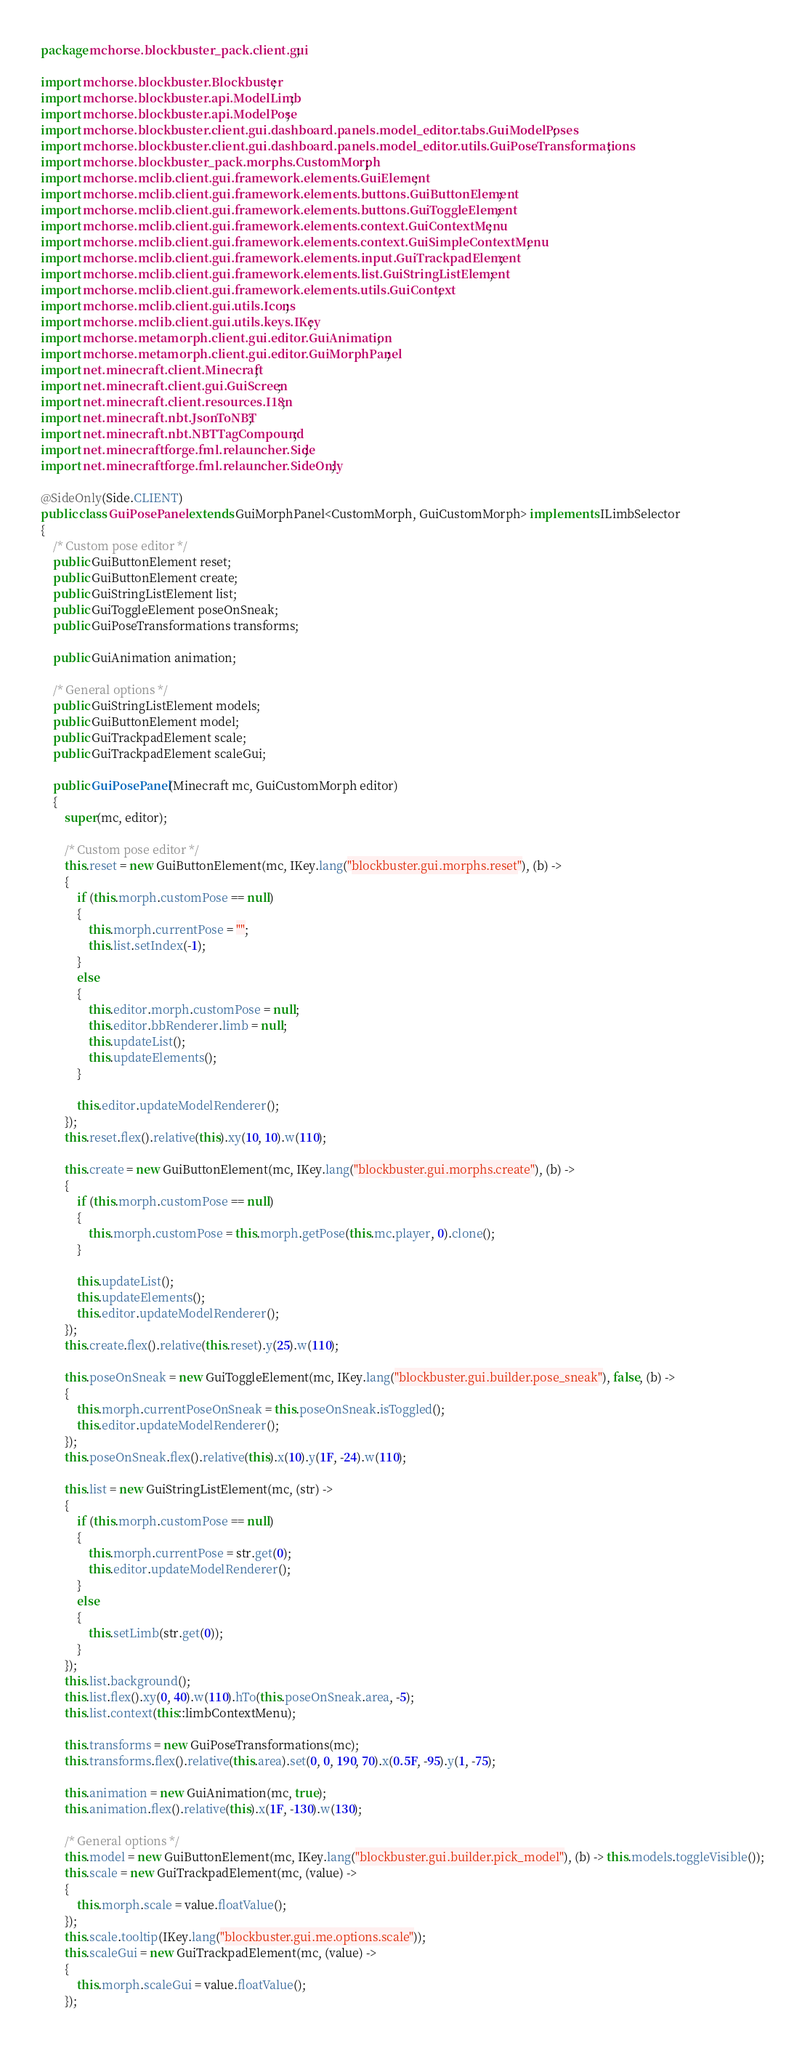Convert code to text. <code><loc_0><loc_0><loc_500><loc_500><_Java_>package mchorse.blockbuster_pack.client.gui;

import mchorse.blockbuster.Blockbuster;
import mchorse.blockbuster.api.ModelLimb;
import mchorse.blockbuster.api.ModelPose;
import mchorse.blockbuster.client.gui.dashboard.panels.model_editor.tabs.GuiModelPoses;
import mchorse.blockbuster.client.gui.dashboard.panels.model_editor.utils.GuiPoseTransformations;
import mchorse.blockbuster_pack.morphs.CustomMorph;
import mchorse.mclib.client.gui.framework.elements.GuiElement;
import mchorse.mclib.client.gui.framework.elements.buttons.GuiButtonElement;
import mchorse.mclib.client.gui.framework.elements.buttons.GuiToggleElement;
import mchorse.mclib.client.gui.framework.elements.context.GuiContextMenu;
import mchorse.mclib.client.gui.framework.elements.context.GuiSimpleContextMenu;
import mchorse.mclib.client.gui.framework.elements.input.GuiTrackpadElement;
import mchorse.mclib.client.gui.framework.elements.list.GuiStringListElement;
import mchorse.mclib.client.gui.framework.elements.utils.GuiContext;
import mchorse.mclib.client.gui.utils.Icons;
import mchorse.mclib.client.gui.utils.keys.IKey;
import mchorse.metamorph.client.gui.editor.GuiAnimation;
import mchorse.metamorph.client.gui.editor.GuiMorphPanel;
import net.minecraft.client.Minecraft;
import net.minecraft.client.gui.GuiScreen;
import net.minecraft.client.resources.I18n;
import net.minecraft.nbt.JsonToNBT;
import net.minecraft.nbt.NBTTagCompound;
import net.minecraftforge.fml.relauncher.Side;
import net.minecraftforge.fml.relauncher.SideOnly;

@SideOnly(Side.CLIENT)
public class GuiPosePanel extends GuiMorphPanel<CustomMorph, GuiCustomMorph> implements ILimbSelector
{
    /* Custom pose editor */
    public GuiButtonElement reset;
    public GuiButtonElement create;
    public GuiStringListElement list;
    public GuiToggleElement poseOnSneak;
    public GuiPoseTransformations transforms;

    public GuiAnimation animation;

    /* General options */
    public GuiStringListElement models;
    public GuiButtonElement model;
    public GuiTrackpadElement scale;
    public GuiTrackpadElement scaleGui;

    public GuiPosePanel(Minecraft mc, GuiCustomMorph editor)
    {
        super(mc, editor);

        /* Custom pose editor */
        this.reset = new GuiButtonElement(mc, IKey.lang("blockbuster.gui.morphs.reset"), (b) ->
        {
            if (this.morph.customPose == null)
            {
                this.morph.currentPose = "";
                this.list.setIndex(-1);
            }
            else
            {
                this.editor.morph.customPose = null;
                this.editor.bbRenderer.limb = null;
                this.updateList();
                this.updateElements();
            }

            this.editor.updateModelRenderer();
        });
        this.reset.flex().relative(this).xy(10, 10).w(110);

        this.create = new GuiButtonElement(mc, IKey.lang("blockbuster.gui.morphs.create"), (b) ->
        {
            if (this.morph.customPose == null)
            {
                this.morph.customPose = this.morph.getPose(this.mc.player, 0).clone();
            }

            this.updateList();
            this.updateElements();
            this.editor.updateModelRenderer();
        });
        this.create.flex().relative(this.reset).y(25).w(110);

        this.poseOnSneak = new GuiToggleElement(mc, IKey.lang("blockbuster.gui.builder.pose_sneak"), false, (b) ->
        {
            this.morph.currentPoseOnSneak = this.poseOnSneak.isToggled();
            this.editor.updateModelRenderer();
        });
        this.poseOnSneak.flex().relative(this).x(10).y(1F, -24).w(110);

        this.list = new GuiStringListElement(mc, (str) ->
        {
            if (this.morph.customPose == null)
            {
                this.morph.currentPose = str.get(0);
                this.editor.updateModelRenderer();
            }
            else
            {
                this.setLimb(str.get(0));
            }
        });
        this.list.background();
        this.list.flex().xy(0, 40).w(110).hTo(this.poseOnSneak.area, -5);
        this.list.context(this::limbContextMenu);

        this.transforms = new GuiPoseTransformations(mc);
        this.transforms.flex().relative(this.area).set(0, 0, 190, 70).x(0.5F, -95).y(1, -75);

        this.animation = new GuiAnimation(mc, true);
        this.animation.flex().relative(this).x(1F, -130).w(130);

        /* General options */
        this.model = new GuiButtonElement(mc, IKey.lang("blockbuster.gui.builder.pick_model"), (b) -> this.models.toggleVisible());
        this.scale = new GuiTrackpadElement(mc, (value) ->
        {
            this.morph.scale = value.floatValue();
        });
        this.scale.tooltip(IKey.lang("blockbuster.gui.me.options.scale"));
        this.scaleGui = new GuiTrackpadElement(mc, (value) ->
        {
            this.morph.scaleGui = value.floatValue();
        });</code> 